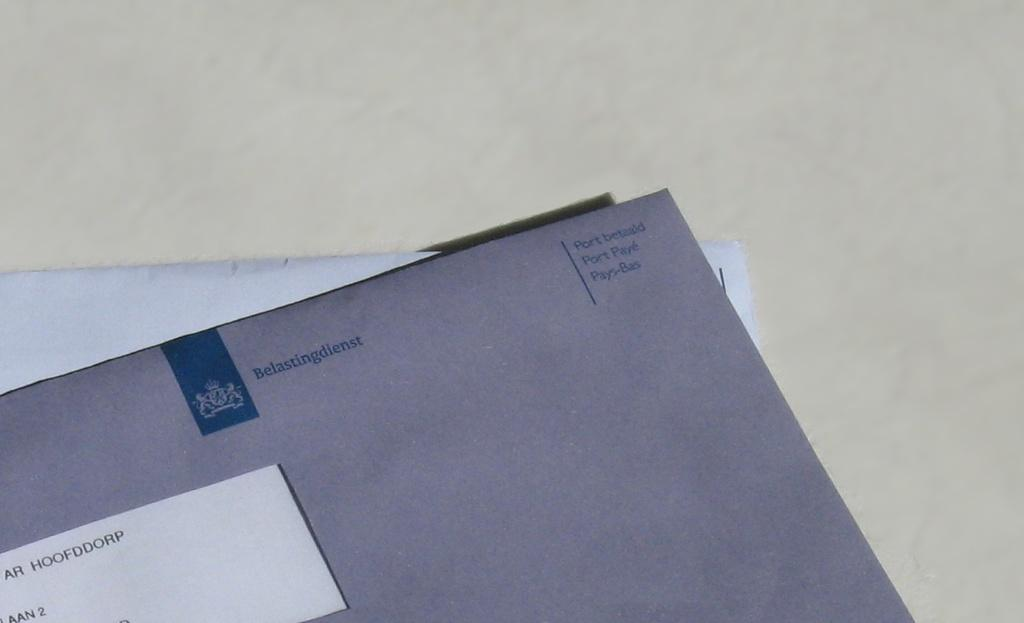Provide a one-sentence caption for the provided image. An envelope from Belastingdienst on top of a stack. 